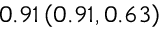<formula> <loc_0><loc_0><loc_500><loc_500>0 . 9 1 \left ( 0 . 9 1 , 0 . 6 3 \right )</formula> 